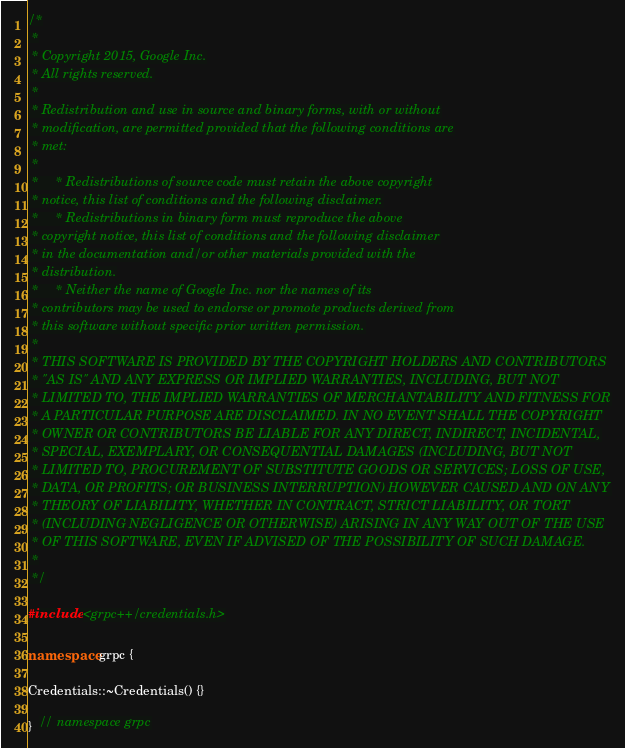Convert code to text. <code><loc_0><loc_0><loc_500><loc_500><_C++_>/*
 *
 * Copyright 2015, Google Inc.
 * All rights reserved.
 *
 * Redistribution and use in source and binary forms, with or without
 * modification, are permitted provided that the following conditions are
 * met:
 *
 *     * Redistributions of source code must retain the above copyright
 * notice, this list of conditions and the following disclaimer.
 *     * Redistributions in binary form must reproduce the above
 * copyright notice, this list of conditions and the following disclaimer
 * in the documentation and/or other materials provided with the
 * distribution.
 *     * Neither the name of Google Inc. nor the names of its
 * contributors may be used to endorse or promote products derived from
 * this software without specific prior written permission.
 *
 * THIS SOFTWARE IS PROVIDED BY THE COPYRIGHT HOLDERS AND CONTRIBUTORS
 * "AS IS" AND ANY EXPRESS OR IMPLIED WARRANTIES, INCLUDING, BUT NOT
 * LIMITED TO, THE IMPLIED WARRANTIES OF MERCHANTABILITY AND FITNESS FOR
 * A PARTICULAR PURPOSE ARE DISCLAIMED. IN NO EVENT SHALL THE COPYRIGHT
 * OWNER OR CONTRIBUTORS BE LIABLE FOR ANY DIRECT, INDIRECT, INCIDENTAL,
 * SPECIAL, EXEMPLARY, OR CONSEQUENTIAL DAMAGES (INCLUDING, BUT NOT
 * LIMITED TO, PROCUREMENT OF SUBSTITUTE GOODS OR SERVICES; LOSS OF USE,
 * DATA, OR PROFITS; OR BUSINESS INTERRUPTION) HOWEVER CAUSED AND ON ANY
 * THEORY OF LIABILITY, WHETHER IN CONTRACT, STRICT LIABILITY, OR TORT
 * (INCLUDING NEGLIGENCE OR OTHERWISE) ARISING IN ANY WAY OUT OF THE USE
 * OF THIS SOFTWARE, EVEN IF ADVISED OF THE POSSIBILITY OF SUCH DAMAGE.
 *
 */

#include <grpc++/credentials.h>

namespace grpc {

Credentials::~Credentials() {}

}  // namespace grpc
</code> 